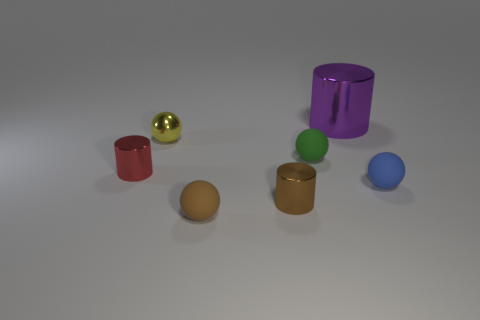Add 3 yellow metallic spheres. How many objects exist? 10 Subtract all spheres. How many objects are left? 3 Subtract 1 red cylinders. How many objects are left? 6 Subtract all big blue balls. Subtract all rubber spheres. How many objects are left? 4 Add 6 blue matte objects. How many blue matte objects are left? 7 Add 7 purple metallic things. How many purple metallic things exist? 8 